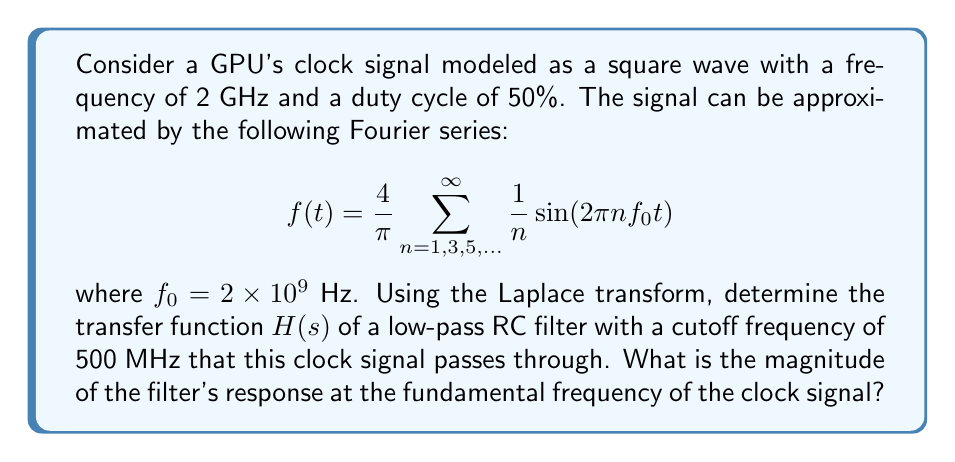Can you solve this math problem? Let's approach this step-by-step:

1) First, we need to determine the transfer function of the low-pass RC filter. The general form is:

   $$H(s) = \frac{1}{1 + sRC}$$

   where $R$ is resistance and $C$ is capacitance.

2) The cutoff frequency $f_c$ is given as 500 MHz. We know that for an RC filter:

   $$f_c = \frac{1}{2\pi RC}$$

3) Rearranging this, we get:

   $$RC = \frac{1}{2\pi f_c} = \frac{1}{2\pi (500 \times 10^6)} = 3.18 \times 10^{-10}$$

4) Substituting this into our transfer function:

   $$H(s) = \frac{1}{1 + s(3.18 \times 10^{-10})}$$

5) To find the magnitude of the response at the fundamental frequency, we need to evaluate $|H(j\omega)|$ where $\omega = 2\pi f_0 = 2\pi(2 \times 10^9)$.

6) Substituting $s$ with $j\omega$:

   $$|H(j\omega)| = \left|\frac{1}{1 + j\omega(3.18 \times 10^{-10})}\right|$$

7) Simplifying:

   $$|H(j\omega)| = \frac{1}{\sqrt{1 + (\omega(3.18 \times 10^{-10}))^2}}$$

8) Plugging in the value for $\omega$:

   $$|H(j\omega)| = \frac{1}{\sqrt{1 + (2\pi(2 \times 10^9)(3.18 \times 10^{-10}))^2}}$$

9) Calculating:

   $$|H(j\omega)| = \frac{1}{\sqrt{1 + (4\pi)^2}} \approx 0.2251$$
Answer: The magnitude of the filter's response at the fundamental frequency of the clock signal is approximately 0.2251 or 22.51%. 